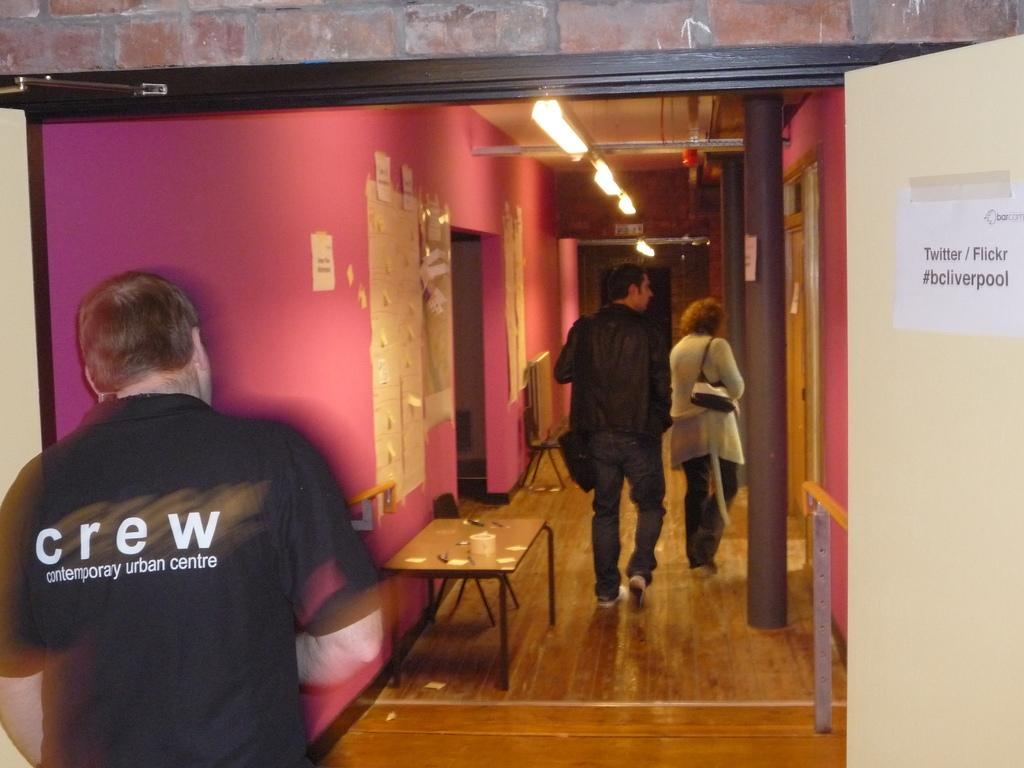How many people are in the image? There are three persons in the image. Where are the persons located in the image? The persons are on a path in the image. What other objects or structures can be seen in the image? There is a table and a wall in the image. What is attached to the wall? There are papers on the wall in the image. What can be seen in the image that provides light? There are lights visible in the image. What type of stamp can be seen on the papers attached to the wall? There is no stamp visible on the papers attached to the wall in the image. 